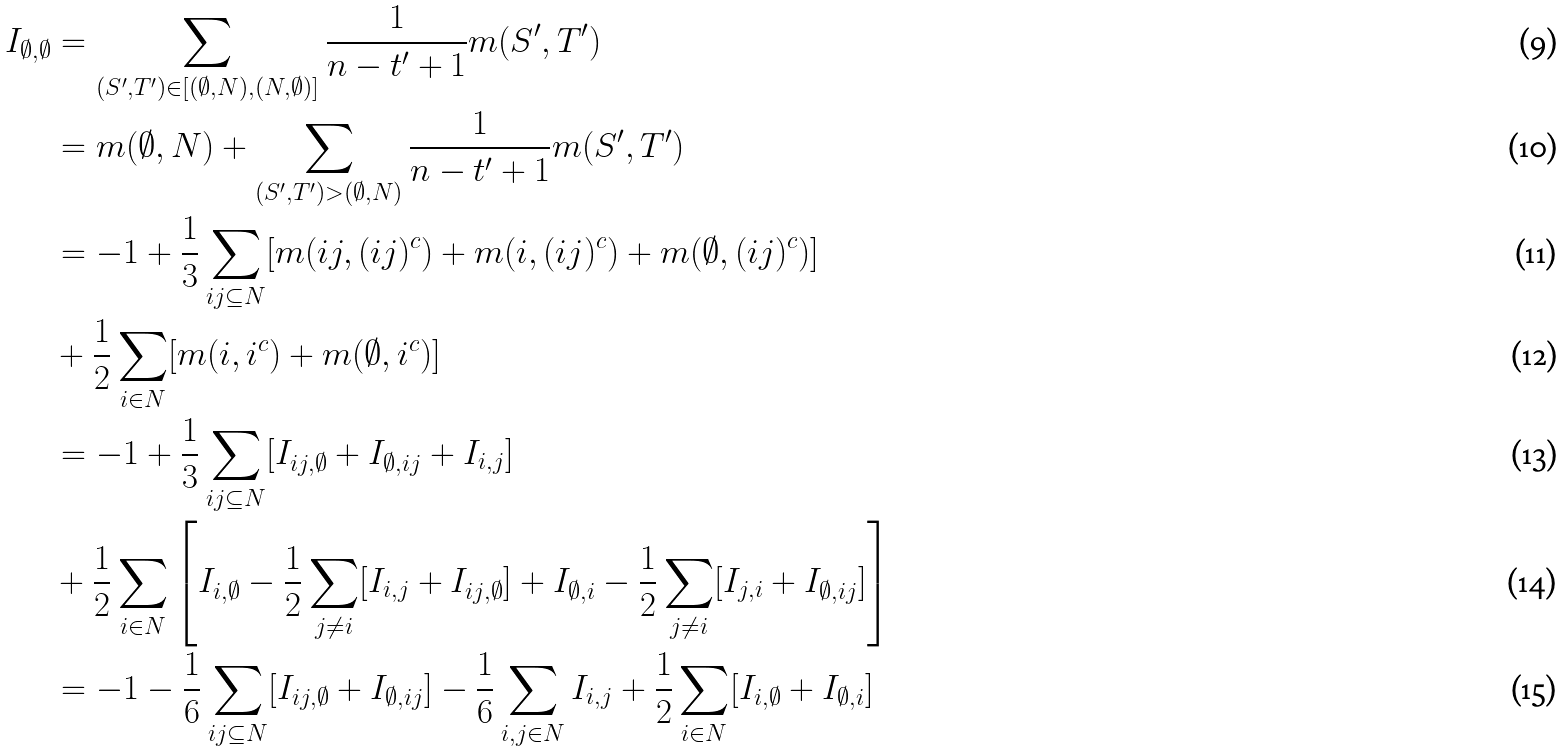<formula> <loc_0><loc_0><loc_500><loc_500>I _ { \emptyset , \emptyset } & = \sum _ { ( S ^ { \prime } , T ^ { \prime } ) \in [ ( \emptyset , N ) , ( N , \emptyset ) ] } \frac { 1 } { n - t ^ { \prime } + 1 } m ( S ^ { \prime } , T ^ { \prime } ) \\ & = m ( \emptyset , N ) + \sum _ { ( S ^ { \prime } , T ^ { \prime } ) > ( \emptyset , N ) } \frac { 1 } { n - t ^ { \prime } + 1 } m ( S ^ { \prime } , T ^ { \prime } ) \\ & = - 1 + \frac { 1 } { 3 } \sum _ { i j \subseteq N } [ m ( i j , ( i j ) ^ { c } ) + m ( i , ( i j ) ^ { c } ) + m ( \emptyset , ( i j ) ^ { c } ) ] \\ & + \frac { 1 } { 2 } \sum _ { i \in N } [ m ( i , i ^ { c } ) + m ( \emptyset , i ^ { c } ) ] \\ & = - 1 + \frac { 1 } { 3 } \sum _ { i j \subseteq N } [ I _ { i j , \emptyset } + I _ { \emptyset , i j } + I _ { i , j } ] \\ & + \frac { 1 } { 2 } \sum _ { i \in N } \left [ I _ { i , \emptyset } - \frac { 1 } { 2 } \sum _ { j \neq i } [ I _ { i , j } + I _ { i j , \emptyset } ] + I _ { \emptyset , i } - \frac { 1 } { 2 } \sum _ { j \neq i } [ I _ { j , i } + I _ { \emptyset , i j } ] \right ] \\ & = - 1 - \frac { 1 } { 6 } \sum _ { i j \subseteq N } [ I _ { i j , \emptyset } + I _ { \emptyset , i j } ] - \frac { 1 } { 6 } \sum _ { i , j \in N } I _ { i , j } + \frac { 1 } { 2 } \sum _ { i \in N } [ I _ { i , \emptyset } + I _ { \emptyset , i } ]</formula> 